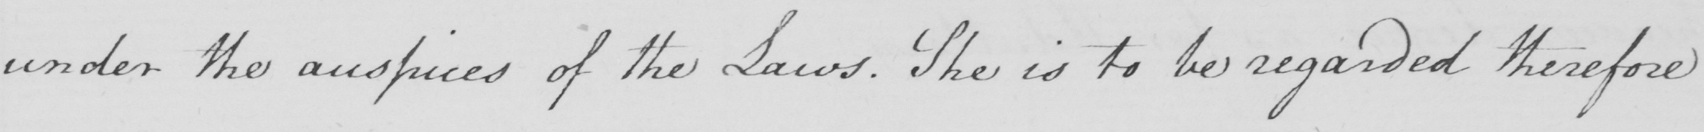Can you tell me what this handwritten text says? under the auspices of the Laws . She is to be regarded therefore 